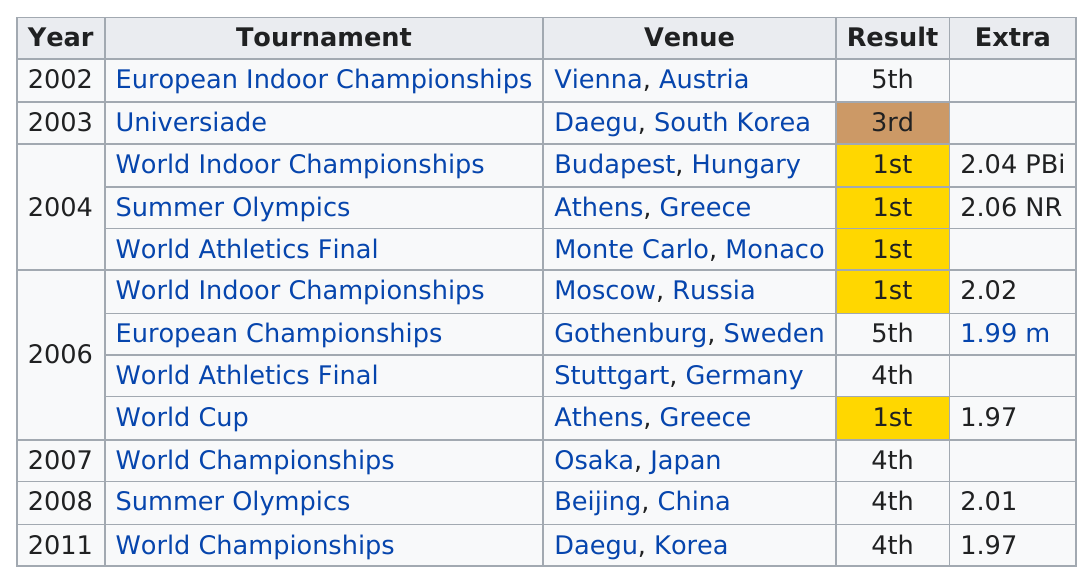Identify some key points in this picture. Yelena Slesarenko has participated in two Summer Olympics. The first year in which the result was first place was 2004. The first-place result did not occur after the year 2006. Yelena Slesarenko had a 1st place finish at the World Indoor Championships in 2006. The venue in Greece was visited two times. 